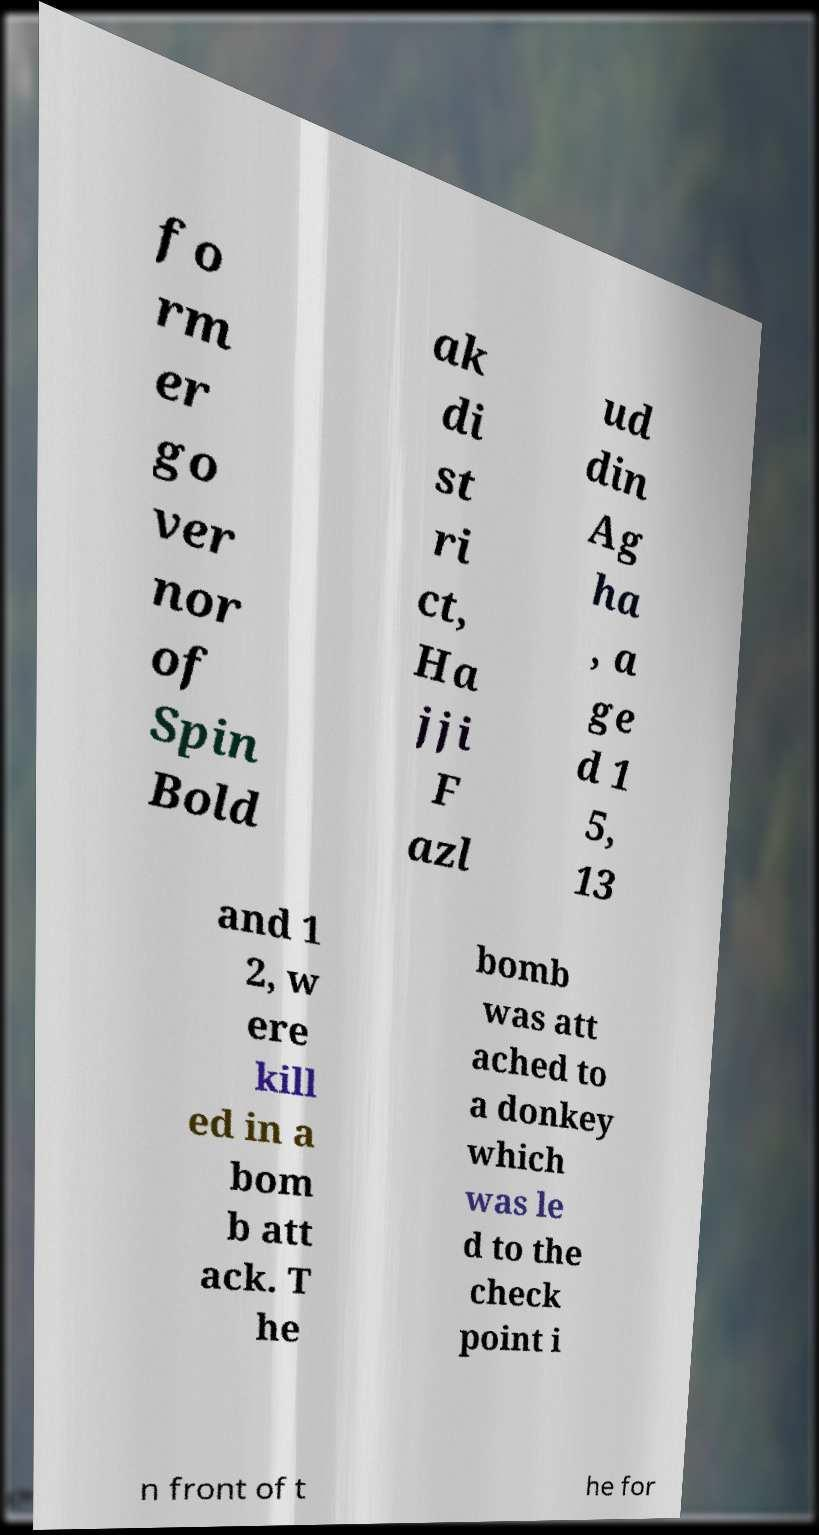What messages or text are displayed in this image? I need them in a readable, typed format. fo rm er go ver nor of Spin Bold ak di st ri ct, Ha jji F azl ud din Ag ha , a ge d 1 5, 13 and 1 2, w ere kill ed in a bom b att ack. T he bomb was att ached to a donkey which was le d to the check point i n front of t he for 